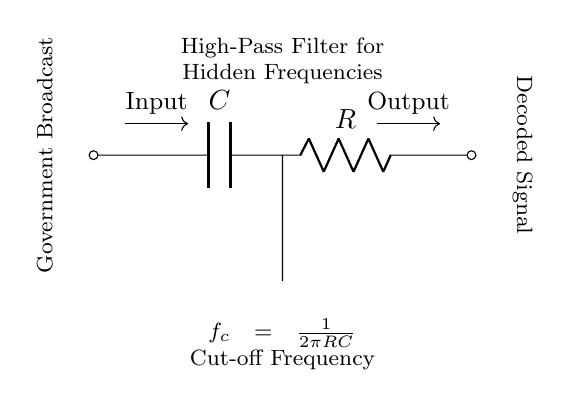What type of filter is this circuit? The circuit is a high-pass filter, which is designed to allow high-frequency signals to pass through while attenuating low-frequency signals. The presence of a capacitor and resistor arranged in this manner confirms this type.
Answer: high-pass filter What components are used in this circuit? The circuit contains a capacitor (C) and a resistor (R) as its main components. These two elements are fundamental for the functioning of a high-pass filter, allowing it to filter out low frequencies.
Answer: capacitor and resistor What is the function of the capacitor in this circuit? The capacitor blocks DC signals and allows AC signals to pass, enhancing the circuit’s ability to filter out low-frequency noise while allowing higher frequencies to pass through.
Answer: blocks DC signals What is the cut-off frequency formula in this circuit? The cut-off frequency is calculated using the formula f_c = 1/(2πRC), which shows the relationship between the resistor (R), capacitor (C), and the frequency at which the circuit starts to allow higher frequencies to pass.
Answer: f_c = 1/(2πRC) Where is the input signal applied in this circuit? The input signal is applied at the left side of the circuit where the arrow points, indicating the entry point for the signal before it is processed by the filter.
Answer: left side What does the output signal represent in this circuit? The output signal on the right side represents the filtered signal, which has had low-frequency components removed, allowing only higher frequencies to be decoded and analyzed.
Answer: filtered signal How are the components connected in this circuit? The components are connected in series: the capacitor is connected to the input, followed by the resistor, which then connects to the output, effectively forming a flow from input to output through both components.
Answer: in series 